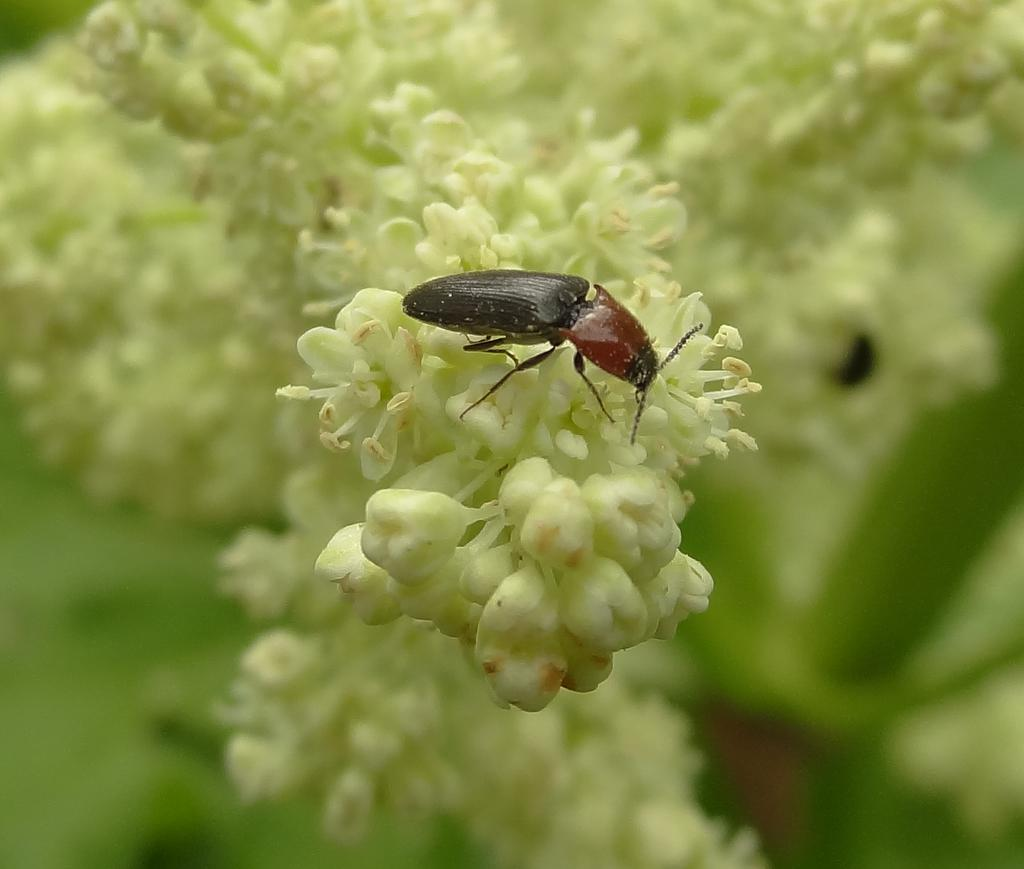What is present in the image? There is a bug in the image. What is the bug standing on? The bug is standing on flowers. What type of joke can be seen in the image? There is no joke present in the image; it features a bug standing on flowers. What type of treatment is being administered to the bushes in the image? There are no bushes or treatments present in the image; it features a bug standing on flowers. 